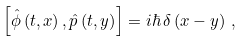<formula> <loc_0><loc_0><loc_500><loc_500>\left [ \hat { \phi } \left ( t , x \right ) , \hat { p } \left ( t , y \right ) \right ] = i \hbar { \, } \delta \left ( x - y \right ) \, ,</formula> 